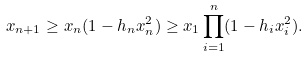<formula> <loc_0><loc_0><loc_500><loc_500>x _ { n + 1 } \geq x _ { n } ( 1 - h _ { n } x _ { n } ^ { 2 } ) \geq x _ { 1 } \prod _ { i = 1 } ^ { n } ( 1 - h _ { i } x _ { i } ^ { 2 } ) .</formula> 